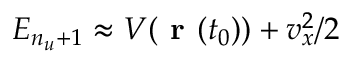Convert formula to latex. <formula><loc_0><loc_0><loc_500><loc_500>E _ { n _ { u } + 1 } \approx V ( r ( t _ { 0 } ) ) + v _ { x } ^ { 2 } / 2</formula> 